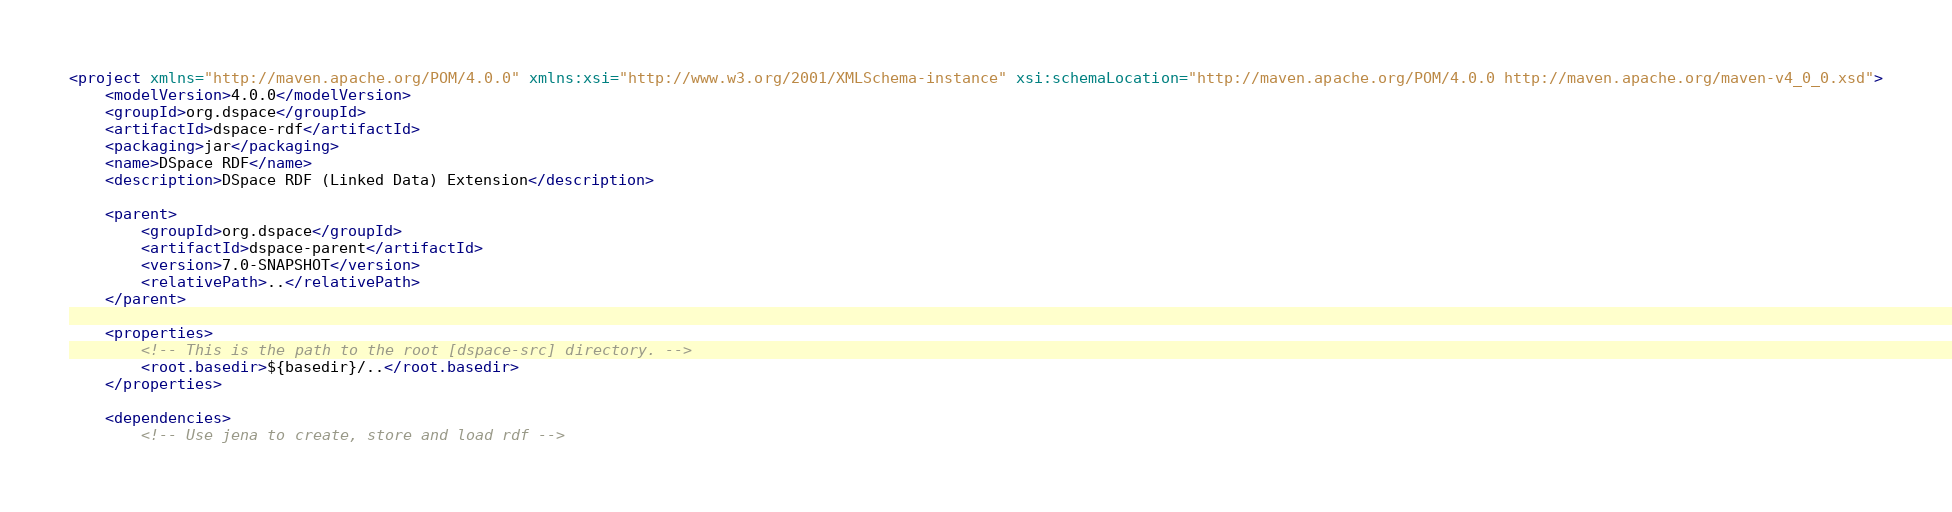Convert code to text. <code><loc_0><loc_0><loc_500><loc_500><_XML_><project xmlns="http://maven.apache.org/POM/4.0.0" xmlns:xsi="http://www.w3.org/2001/XMLSchema-instance" xsi:schemaLocation="http://maven.apache.org/POM/4.0.0 http://maven.apache.org/maven-v4_0_0.xsd">
    <modelVersion>4.0.0</modelVersion>
    <groupId>org.dspace</groupId>
    <artifactId>dspace-rdf</artifactId>
    <packaging>jar</packaging>
    <name>DSpace RDF</name>
    <description>DSpace RDF (Linked Data) Extension</description>

    <parent>
        <groupId>org.dspace</groupId>
        <artifactId>dspace-parent</artifactId>
        <version>7.0-SNAPSHOT</version>
        <relativePath>..</relativePath>
    </parent>

    <properties>
        <!-- This is the path to the root [dspace-src] directory. -->
        <root.basedir>${basedir}/..</root.basedir>
    </properties>

    <dependencies>
        <!-- Use jena to create, store and load rdf --></code> 